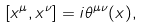Convert formula to latex. <formula><loc_0><loc_0><loc_500><loc_500>[ x ^ { \mu } , x ^ { \nu } ] = i \theta ^ { \mu \nu } ( x ) ,</formula> 